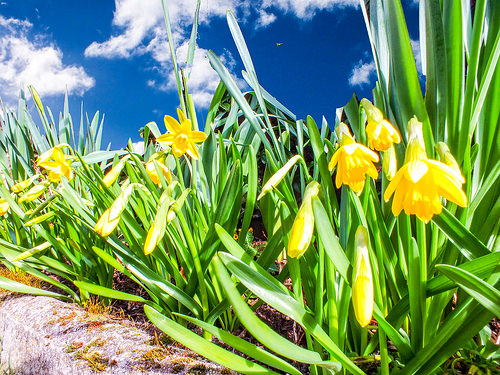<image>
Is there a flower on the stem? Yes. Looking at the image, I can see the flower is positioned on top of the stem, with the stem providing support. 